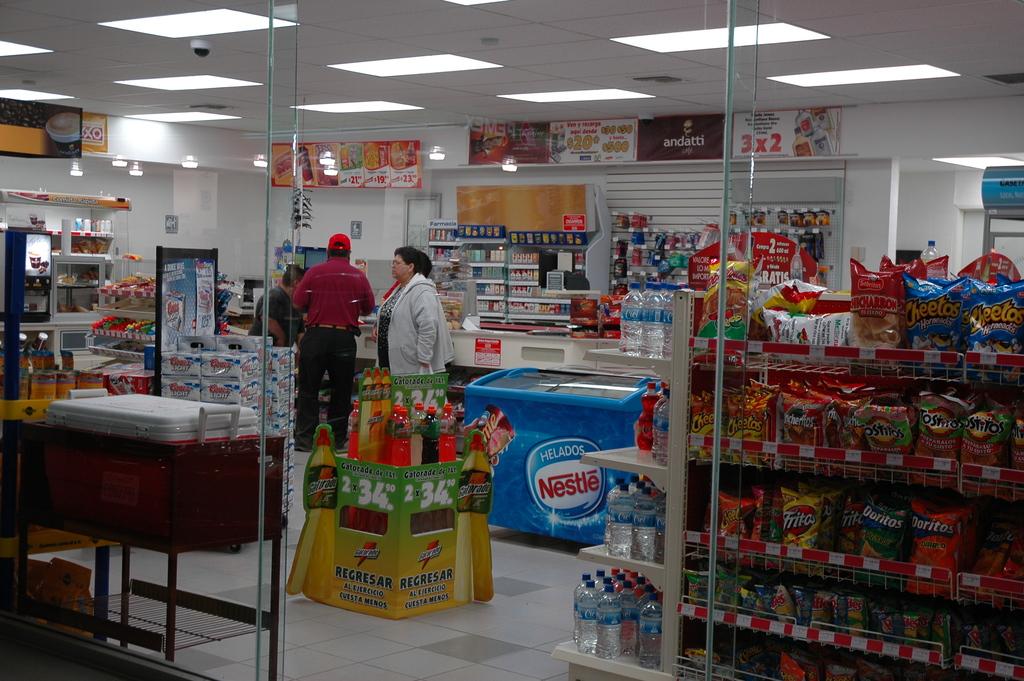What brand is on the blue freezer?
Keep it short and to the point. Nestle. What is the middle display area selling?
Your answer should be very brief. Gatorade. 